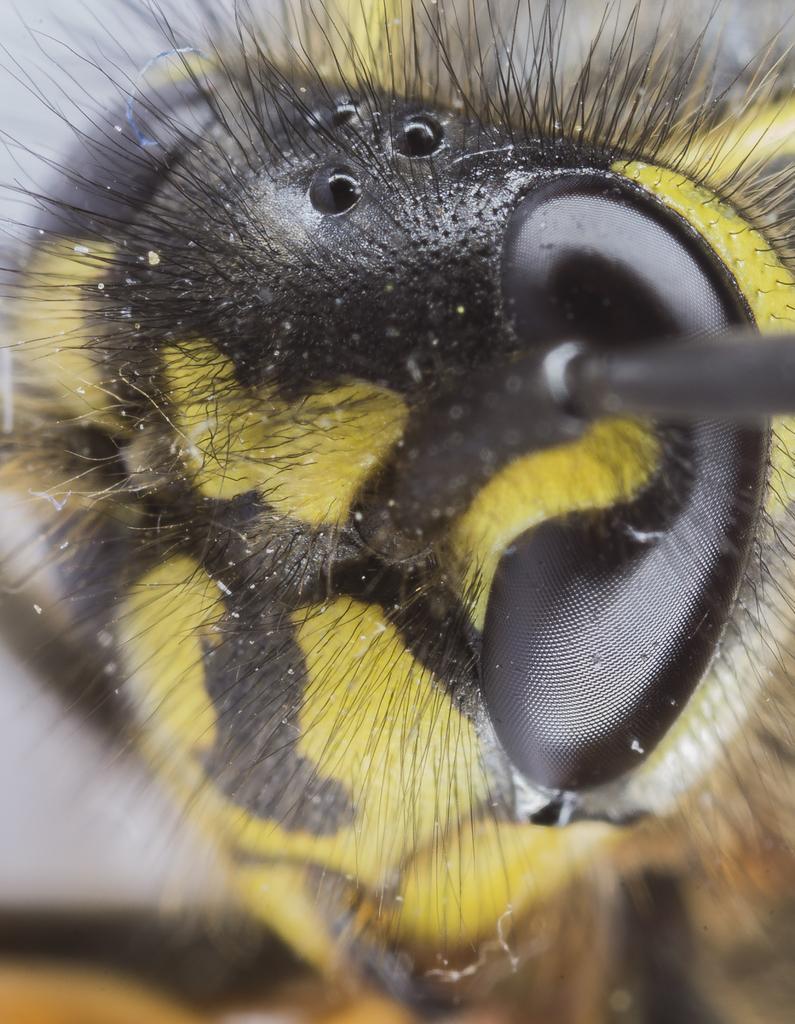In one or two sentences, can you explain what this image depicts? In the picture we can see a close view of an insect with an eye, hair and some part yellow in color and some part black in color. 